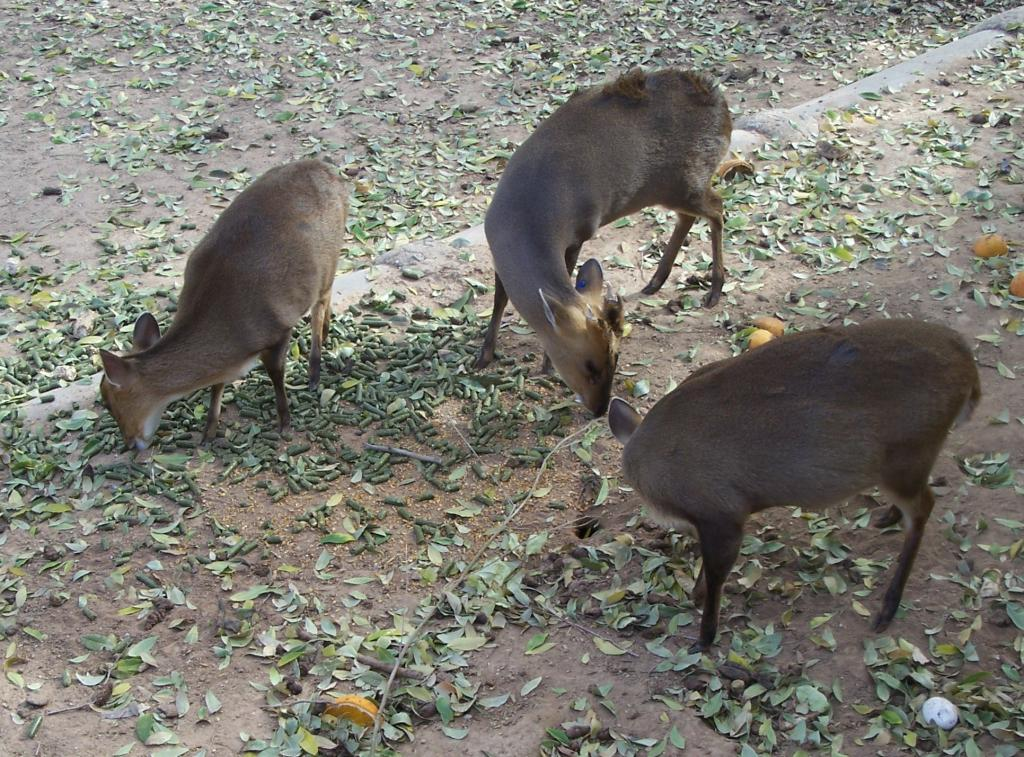What type of surface can be seen in the image? There is ground visible in the image. What is present on the ground? There are leaves on the ground. What object can be seen in the image besides the ground and leaves? There is a pipe in the image. How many brown animals are standing on the ground in the image? There are three brown animals standing on the ground in the image. What type of produce is being harvested by the animals in the image? There is no produce or harvesting activity depicted in the image; it only shows three brown animals standing on the ground. 